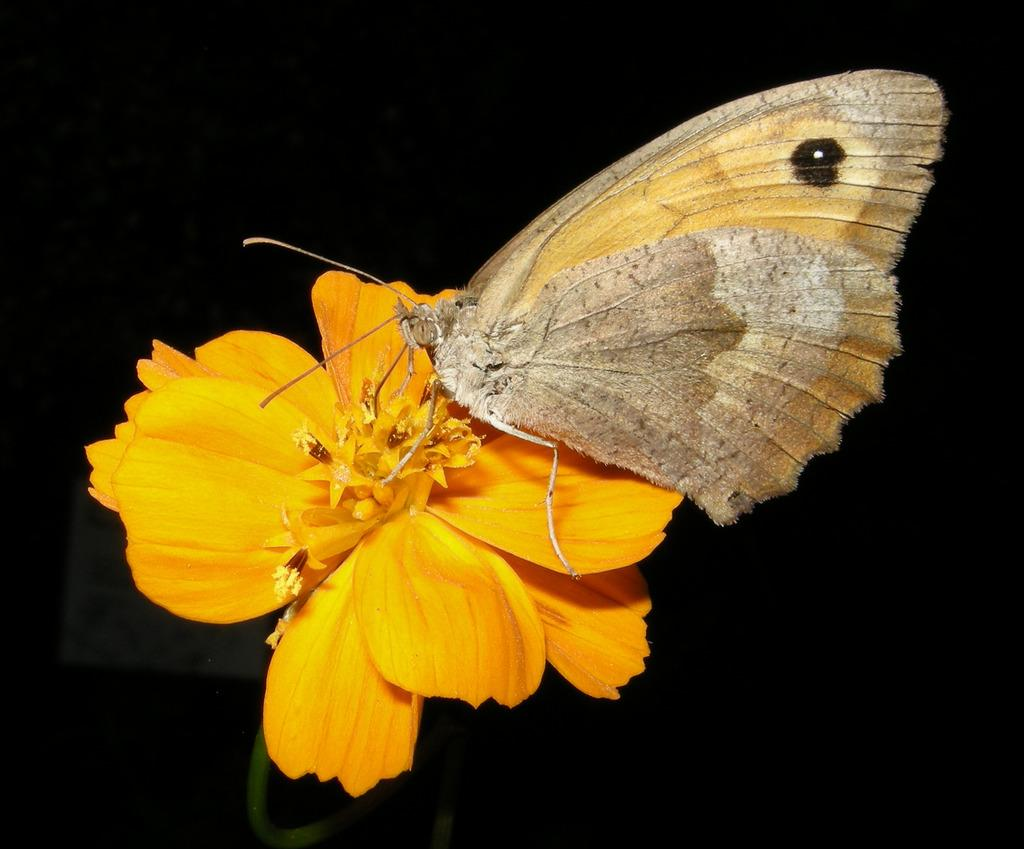What type of living organism can be seen in the image? There is a flower and a butterfly in the image. What is the color of the background in the image? The background of the image is dark. What type of wire can be seen connecting the flower and the butterfly in the image? There is no wire connecting the flower and the butterfly in the image; they are separate subjects in the image. 